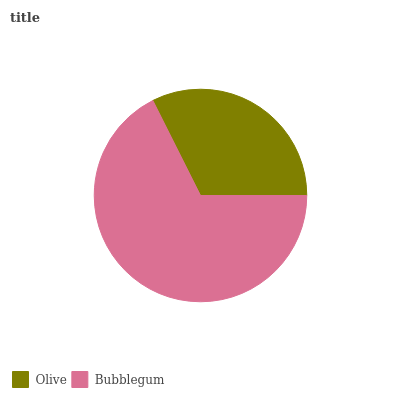Is Olive the minimum?
Answer yes or no. Yes. Is Bubblegum the maximum?
Answer yes or no. Yes. Is Bubblegum the minimum?
Answer yes or no. No. Is Bubblegum greater than Olive?
Answer yes or no. Yes. Is Olive less than Bubblegum?
Answer yes or no. Yes. Is Olive greater than Bubblegum?
Answer yes or no. No. Is Bubblegum less than Olive?
Answer yes or no. No. Is Bubblegum the high median?
Answer yes or no. Yes. Is Olive the low median?
Answer yes or no. Yes. Is Olive the high median?
Answer yes or no. No. Is Bubblegum the low median?
Answer yes or no. No. 